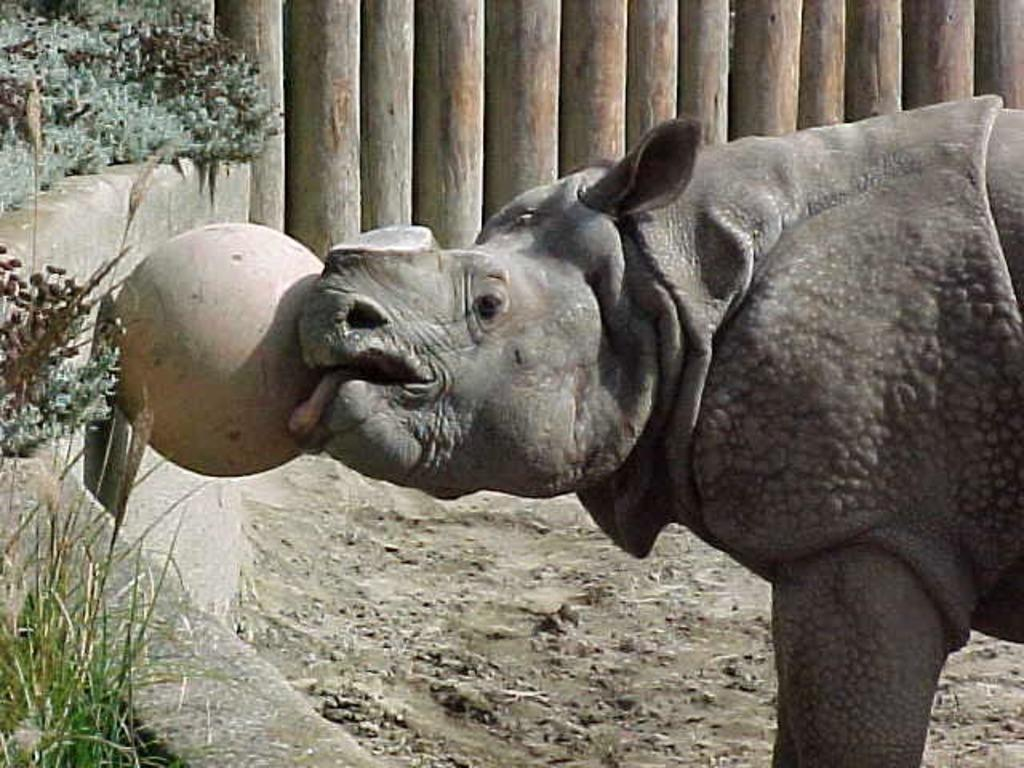What type of living creature is in the image? There is an animal in the image. What is the background of the image made of? There is a wall in the image. What is used to enclose the area in the image? There is a fence in the image. What type of vegetation can be seen in the image? There are plants in the image. What type of ground cover is present in the image? There is grass in the image. What type of surface is beneath the plants and grass in the image? There is soil in the image. How many trees are visible in the image? There are no trees visible in the image. 